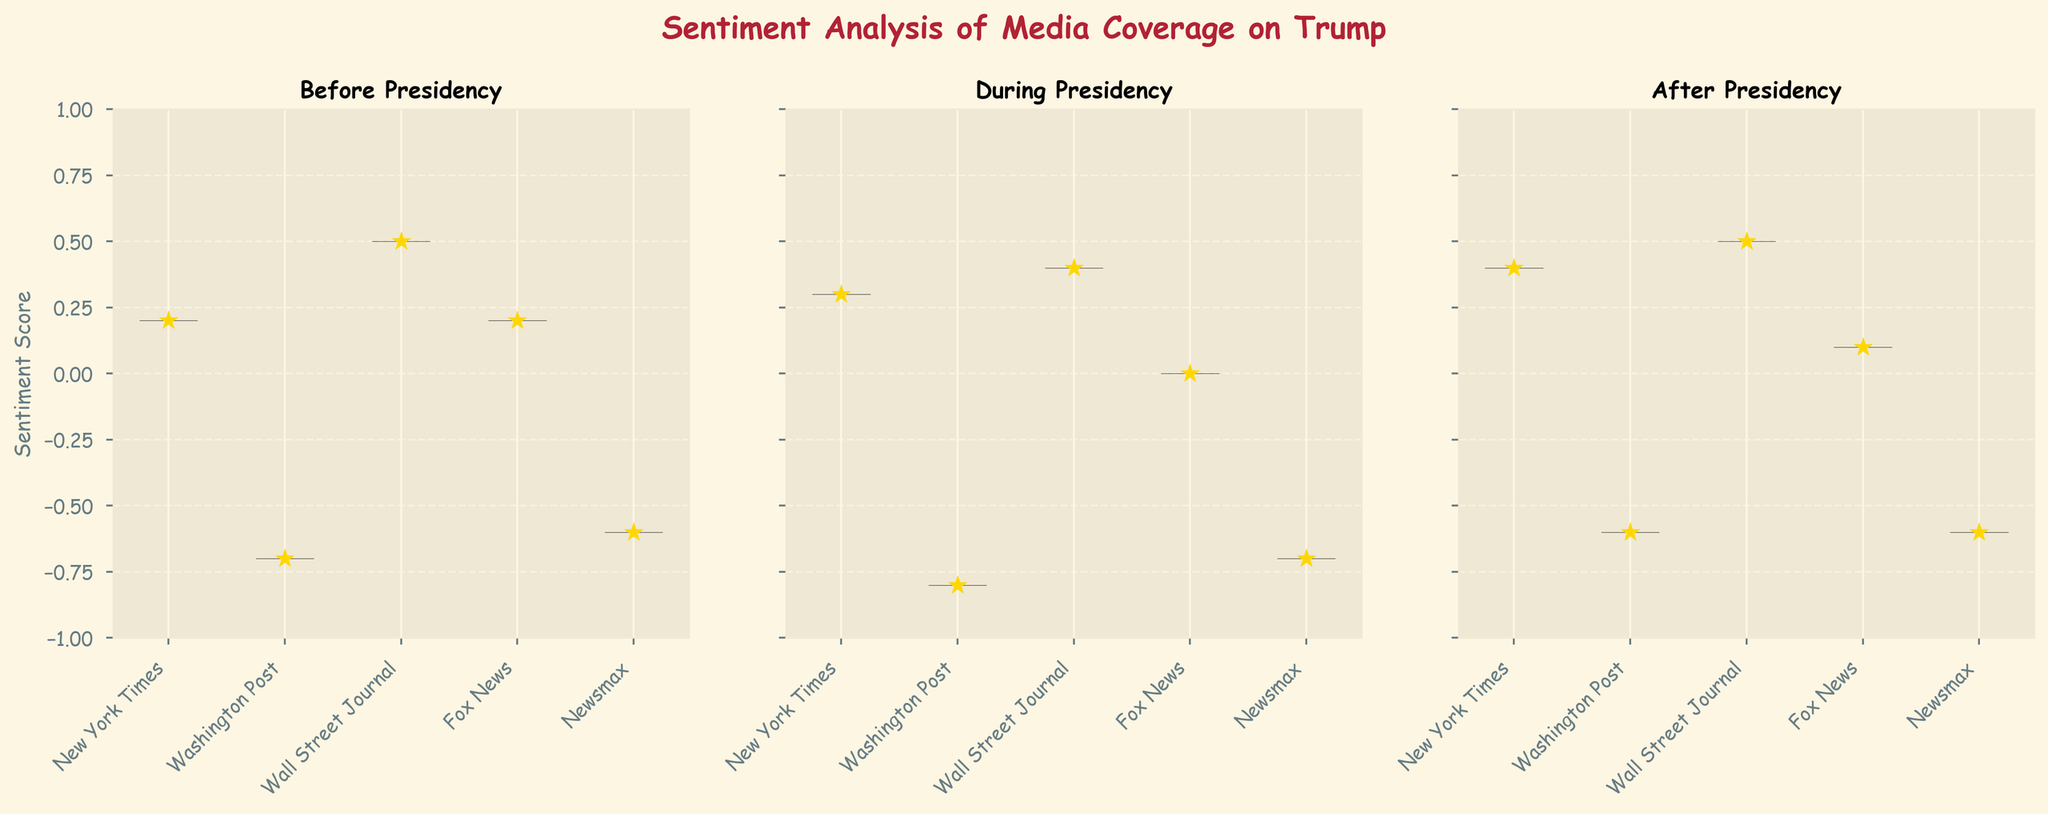What's the title of the figure? The title is located at the top of the figure. The text should be prominent and usually summarizes the overall topic of the figure.
Answer: Sentiment Analysis of Media Coverage on Trump Which period has the most positive sentiment from Fox News? Look at the violin plots grouping by period, identify the one with the highest positive sentiment for Fox News. The average sentiment (marked by a star) can help assess this.
Answer: After Presidency What are the sentiment score ranges for the Washington Post during Trump's presidency? Inspect the violin plot corresponding to the Washington Post under the "During Presidency" subplot. The range extends from the lowest point to the highest within the shaded area of the plot.
Answer: -0.7 to -0.7 Which media source had the most consistent sentiment over all three periods? Compare the widths of the violin plots' bodies across all periods for each source. The narrower and more consistently positioned plots indicate a more stable sentiment.
Answer: Wall Street Journal How does the average sentiment for Newsmax during Trump's presidency compare to before his presidency? Compare the mean values indicated by star markers in the Newsmax violin plots for the "During Presidency" and "Before Presidency" subplots.
Answer: Lower during the presidency What's the median sentiment score for the New York Times before Trump's presidency? The actual median is depicted by the thickest part of the violin plot for the New York Times in the "Before Presidency" subplot.
Answer: -0.7 Which period shows the widest range of sentiment scores for the New York Times? Observe the span (from the lowest to highest points) of the violin shapes across different periods for the New York Times.
Answer: During Presidency How does the sentiment distribution for Fox News compare across the three periods? Analyze the shapes and ranges of the Fox News violin plots in all three periods. Wider and more centralized plots indicate a more neutral distribution, while tighter, higher, or lower plots indicate more positive or negative trends.
Answer: More positive after presidency Which media source has a distinctly different sentiment distribution than the others during Trump's presidency? Identify the plot that visually stands out the most in terms of spread, central location, or trend in the "During Presidency" subplot.
Answer: Fox News What's the change in average sentiment of the Washington Post from before to after Trump's presidency? Calculate the difference between the means denoted by stars in the Washington Post plots for "Before Presidency" and "After Presidency".
Answer: No change, both are -0.6 